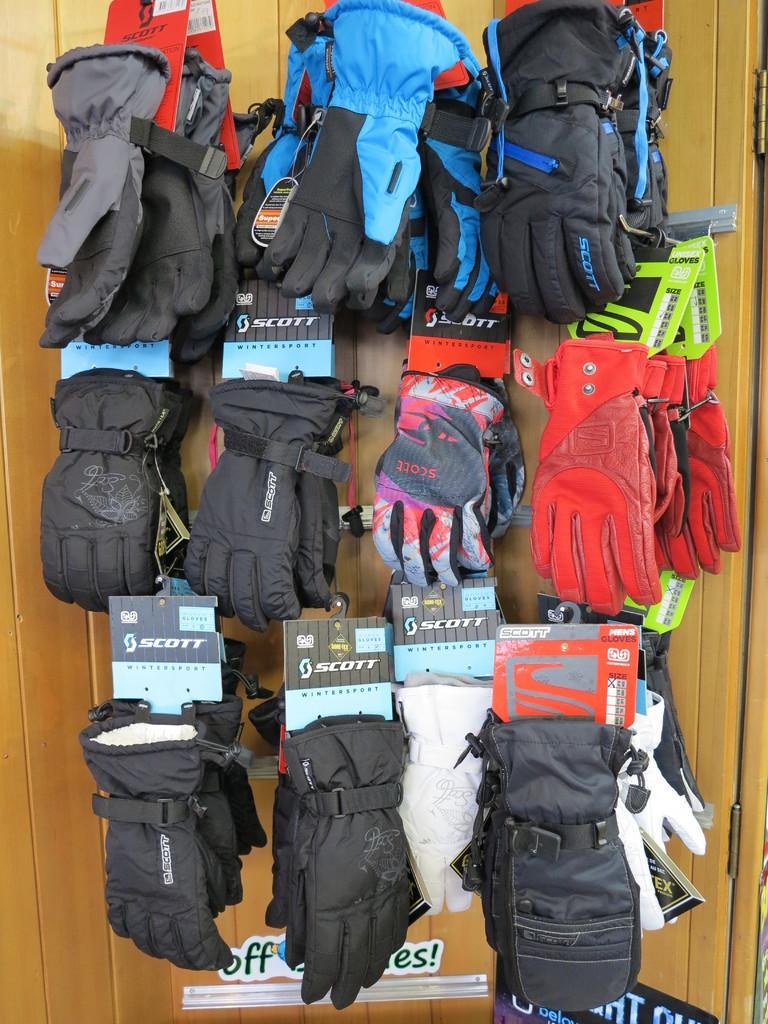Could you give a brief overview of what you see in this image? In this image we can see few pairs of gloves which are changed and they are of different colors like red, blue, black , white and in the background of the image there is brown color surface. 